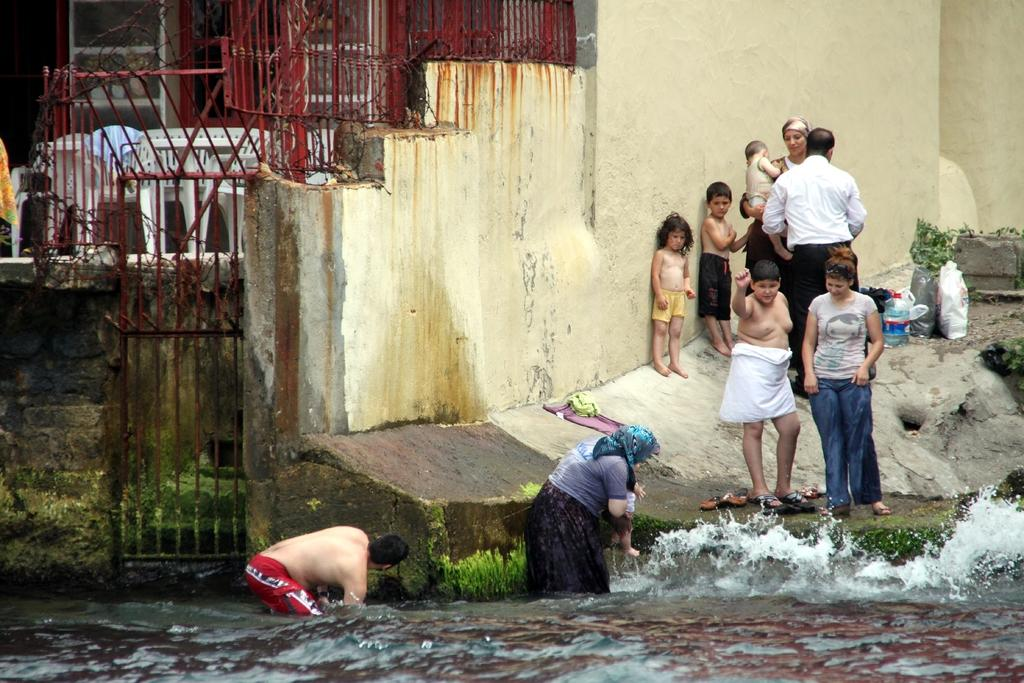What are the people in the image doing? The people in the image are standing in the water. What type of barrier can be seen in the image? There is fencing visible in the image. What type of structures are present in the image? There are walls in the image. What natural element is visible in the image? Water is visible in the image. What type of terrain is present in the image? Rocks and grass are visible in the image. What type of celery is being used as a prop in the image? There is no celery present in the image. Can you describe the girl's outfit in the image? There is no girl present in the image. 